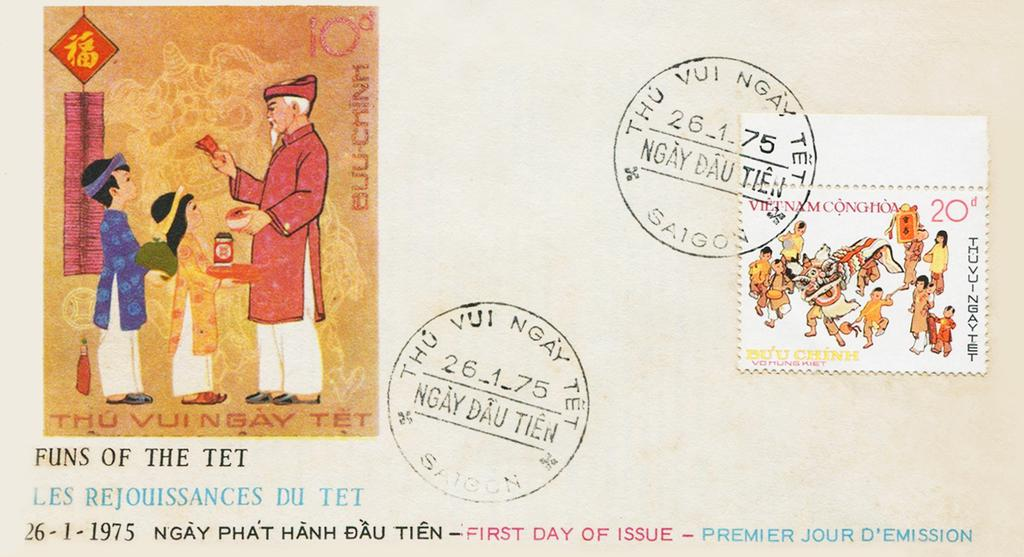<image>
Share a concise interpretation of the image provided. A postcard with a Funs of the Tet picture. 